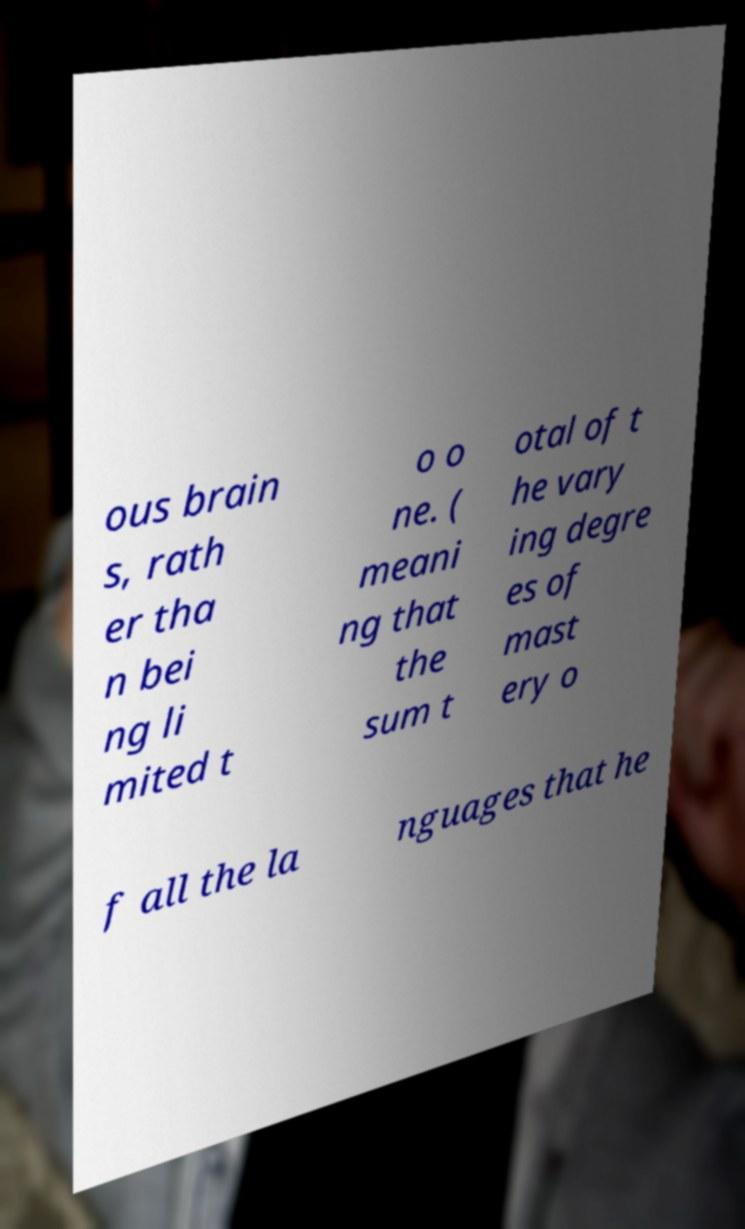There's text embedded in this image that I need extracted. Can you transcribe it verbatim? ous brain s, rath er tha n bei ng li mited t o o ne. ( meani ng that the sum t otal of t he vary ing degre es of mast ery o f all the la nguages that he 